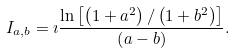<formula> <loc_0><loc_0><loc_500><loc_500>I _ { a , b } = \imath \frac { \ln \left [ \left ( 1 + a ^ { 2 } \right ) / \left ( 1 + b ^ { 2 } \right ) \right ] } { \left ( a - b \right ) } .</formula> 